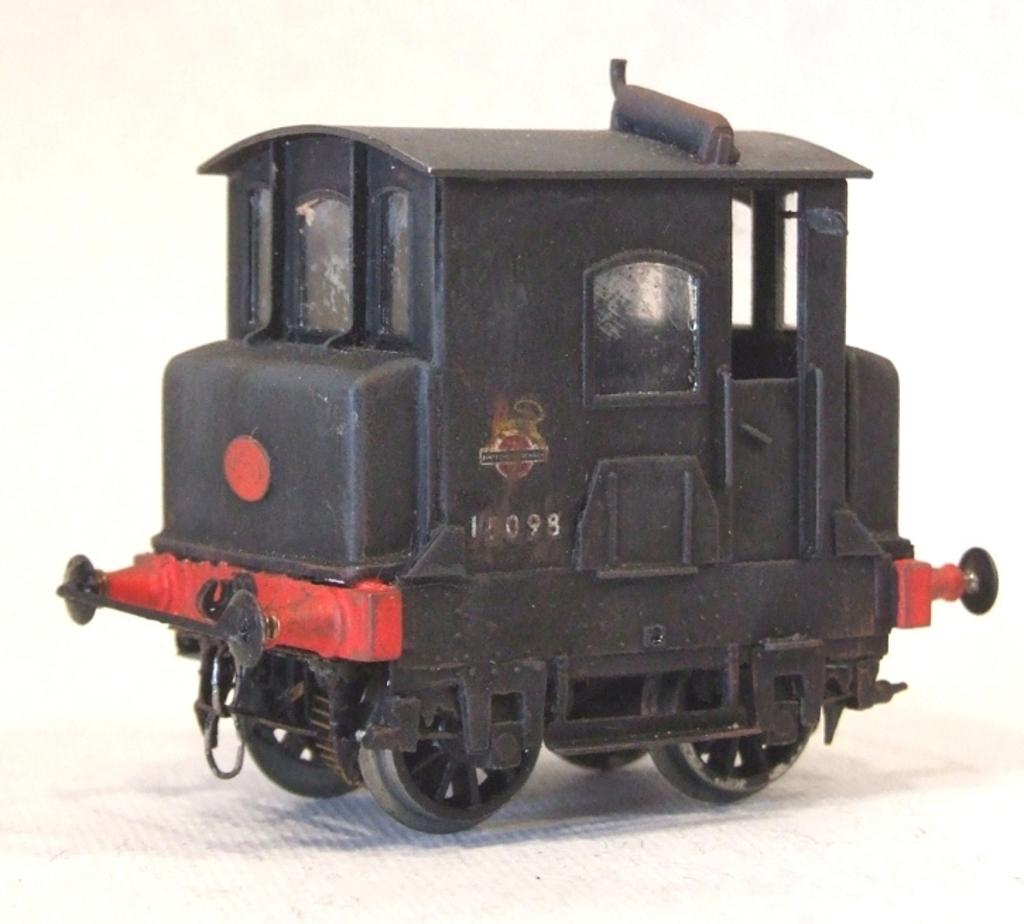What is the color of the vehicle in the image? The vehicle in the image is black. What advice is the vehicle giving to the people in the image? There are no people present in the image, and vehicles do not give advice. 